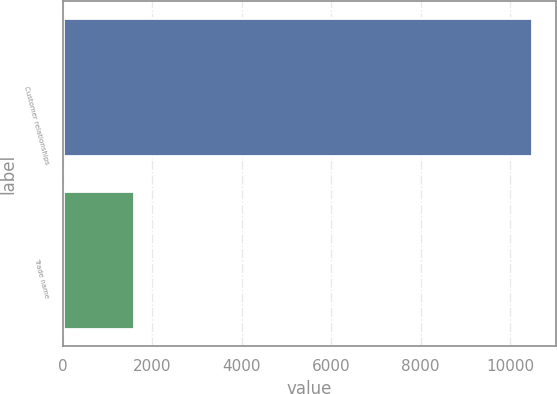<chart> <loc_0><loc_0><loc_500><loc_500><bar_chart><fcel>Customer relationships<fcel>Trade name<nl><fcel>10498<fcel>1597<nl></chart> 